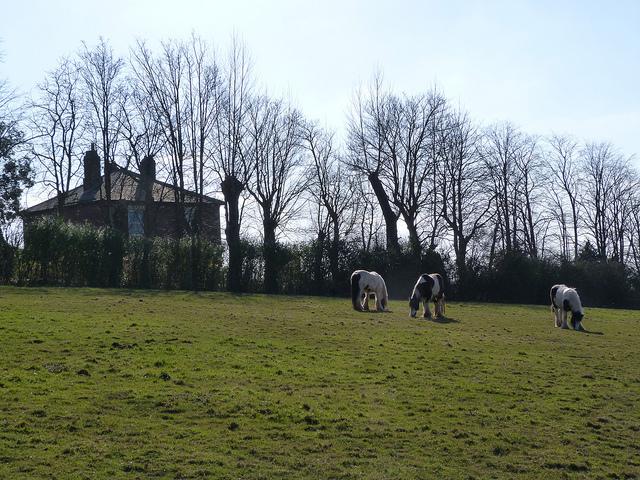Are there mountains in the background?
Be succinct. No. How many sheep are there?
Short answer required. 0. Is there a house behind the trees?
Keep it brief. Yes. What color are the horses' spots?
Give a very brief answer. Brown. How many horses are there?
Short answer required. 3. 